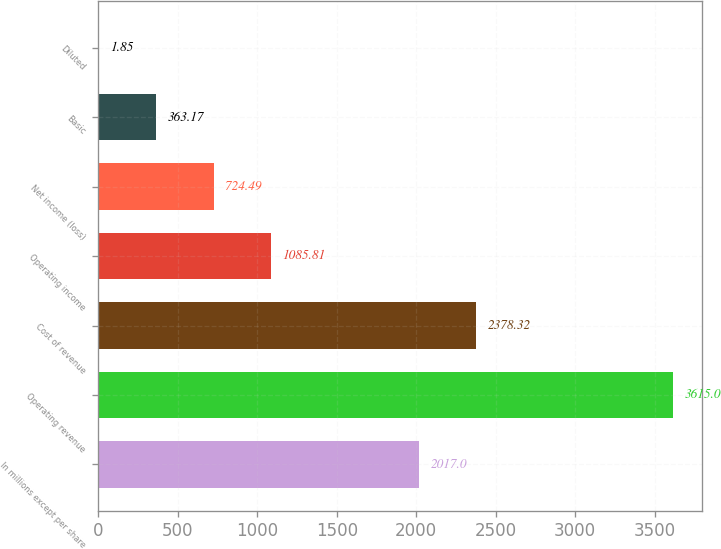Convert chart. <chart><loc_0><loc_0><loc_500><loc_500><bar_chart><fcel>In millions except per share<fcel>Operating revenue<fcel>Cost of revenue<fcel>Operating income<fcel>Net income (loss)<fcel>Basic<fcel>Diluted<nl><fcel>2017<fcel>3615<fcel>2378.32<fcel>1085.81<fcel>724.49<fcel>363.17<fcel>1.85<nl></chart> 